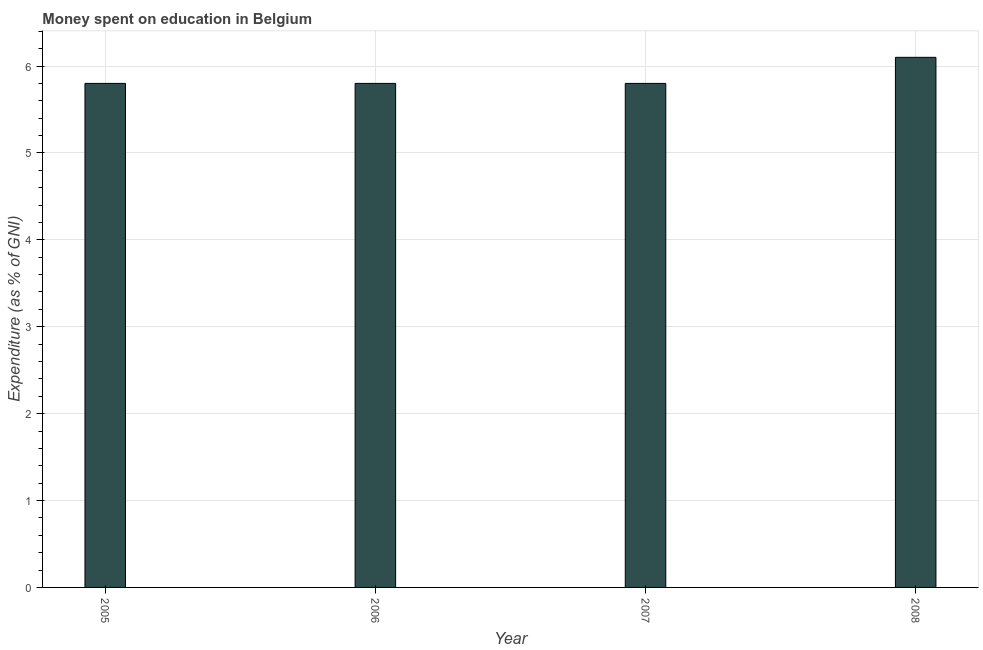Does the graph contain any zero values?
Keep it short and to the point. No. Does the graph contain grids?
Offer a very short reply. Yes. What is the title of the graph?
Give a very brief answer. Money spent on education in Belgium. What is the label or title of the Y-axis?
Your response must be concise. Expenditure (as % of GNI). Across all years, what is the minimum expenditure on education?
Offer a terse response. 5.8. In which year was the expenditure on education minimum?
Offer a very short reply. 2005. What is the sum of the expenditure on education?
Give a very brief answer. 23.5. What is the average expenditure on education per year?
Offer a very short reply. 5.88. Is the difference between the expenditure on education in 2006 and 2007 greater than the difference between any two years?
Offer a very short reply. No. What is the difference between the highest and the second highest expenditure on education?
Your answer should be very brief. 0.3. In how many years, is the expenditure on education greater than the average expenditure on education taken over all years?
Offer a terse response. 1. Are all the bars in the graph horizontal?
Make the answer very short. No. What is the difference between the Expenditure (as % of GNI) in 2005 and 2007?
Keep it short and to the point. 0. What is the difference between the Expenditure (as % of GNI) in 2006 and 2007?
Your response must be concise. 0. What is the difference between the Expenditure (as % of GNI) in 2006 and 2008?
Offer a terse response. -0.3. What is the difference between the Expenditure (as % of GNI) in 2007 and 2008?
Give a very brief answer. -0.3. What is the ratio of the Expenditure (as % of GNI) in 2005 to that in 2007?
Provide a succinct answer. 1. What is the ratio of the Expenditure (as % of GNI) in 2005 to that in 2008?
Give a very brief answer. 0.95. What is the ratio of the Expenditure (as % of GNI) in 2006 to that in 2008?
Your response must be concise. 0.95. What is the ratio of the Expenditure (as % of GNI) in 2007 to that in 2008?
Offer a very short reply. 0.95. 